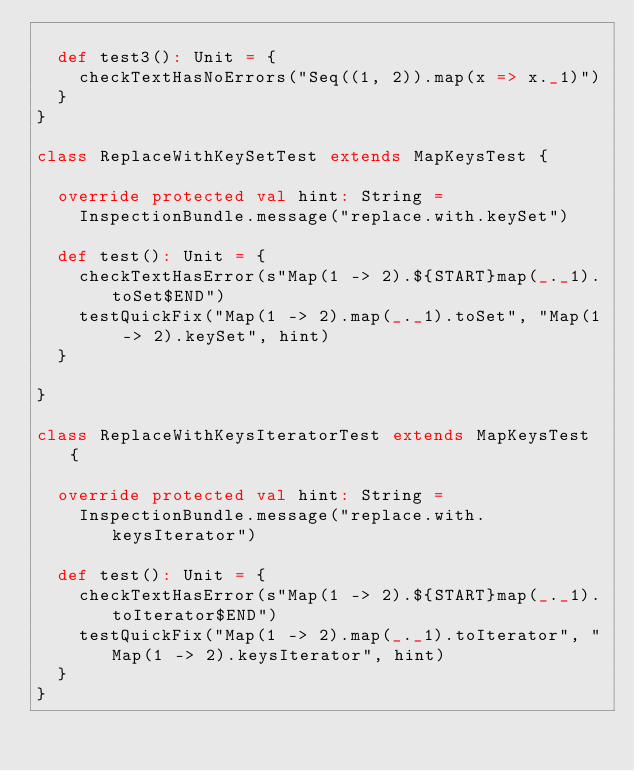Convert code to text. <code><loc_0><loc_0><loc_500><loc_500><_Scala_>
  def test3(): Unit = {
    checkTextHasNoErrors("Seq((1, 2)).map(x => x._1)")
  }
}

class ReplaceWithKeySetTest extends MapKeysTest {

  override protected val hint: String =
    InspectionBundle.message("replace.with.keySet")

  def test(): Unit = {
    checkTextHasError(s"Map(1 -> 2).${START}map(_._1).toSet$END")
    testQuickFix("Map(1 -> 2).map(_._1).toSet", "Map(1 -> 2).keySet", hint)
  }

}

class ReplaceWithKeysIteratorTest extends MapKeysTest {

  override protected val hint: String =
    InspectionBundle.message("replace.with.keysIterator")

  def test(): Unit = {
    checkTextHasError(s"Map(1 -> 2).${START}map(_._1).toIterator$END")
    testQuickFix("Map(1 -> 2).map(_._1).toIterator", "Map(1 -> 2).keysIterator", hint)
  }
}
</code> 